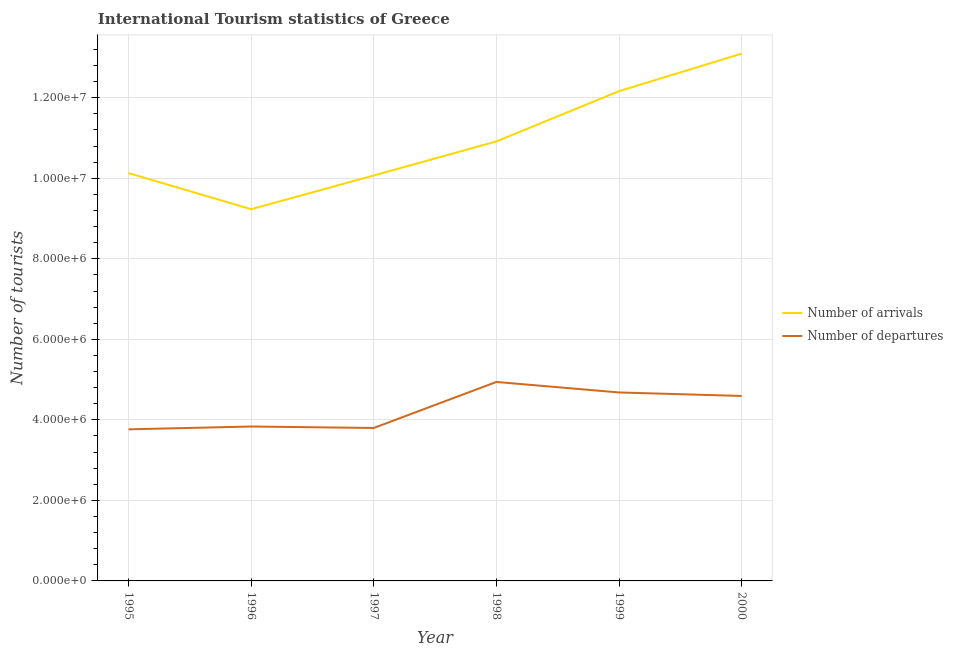How many different coloured lines are there?
Your response must be concise. 2. Does the line corresponding to number of tourist arrivals intersect with the line corresponding to number of tourist departures?
Your response must be concise. No. What is the number of tourist departures in 2000?
Your answer should be compact. 4.59e+06. Across all years, what is the maximum number of tourist departures?
Give a very brief answer. 4.94e+06. Across all years, what is the minimum number of tourist arrivals?
Your answer should be very brief. 9.23e+06. What is the total number of tourist arrivals in the graph?
Offer a terse response. 6.56e+07. What is the difference between the number of tourist departures in 1995 and that in 1998?
Offer a very short reply. -1.18e+06. What is the difference between the number of tourist arrivals in 1999 and the number of tourist departures in 1996?
Provide a succinct answer. 8.33e+06. What is the average number of tourist departures per year?
Make the answer very short. 4.27e+06. In the year 1996, what is the difference between the number of tourist arrivals and number of tourist departures?
Keep it short and to the point. 5.40e+06. What is the ratio of the number of tourist arrivals in 1997 to that in 1998?
Your response must be concise. 0.92. Is the difference between the number of tourist arrivals in 1995 and 1998 greater than the difference between the number of tourist departures in 1995 and 1998?
Your answer should be compact. Yes. What is the difference between the highest and the second highest number of tourist departures?
Your answer should be very brief. 2.61e+05. What is the difference between the highest and the lowest number of tourist departures?
Make the answer very short. 1.18e+06. In how many years, is the number of tourist departures greater than the average number of tourist departures taken over all years?
Make the answer very short. 3. Is the sum of the number of tourist arrivals in 1995 and 2000 greater than the maximum number of tourist departures across all years?
Provide a succinct answer. Yes. Is the number of tourist departures strictly less than the number of tourist arrivals over the years?
Provide a short and direct response. Yes. How many lines are there?
Make the answer very short. 2. How many years are there in the graph?
Provide a succinct answer. 6. What is the difference between two consecutive major ticks on the Y-axis?
Offer a very short reply. 2.00e+06. Does the graph contain grids?
Your response must be concise. Yes. How many legend labels are there?
Provide a short and direct response. 2. How are the legend labels stacked?
Your answer should be very brief. Vertical. What is the title of the graph?
Your answer should be compact. International Tourism statistics of Greece. Does "Resident" appear as one of the legend labels in the graph?
Give a very brief answer. No. What is the label or title of the X-axis?
Ensure brevity in your answer.  Year. What is the label or title of the Y-axis?
Offer a very short reply. Number of tourists. What is the Number of tourists in Number of arrivals in 1995?
Make the answer very short. 1.01e+07. What is the Number of tourists in Number of departures in 1995?
Offer a very short reply. 3.76e+06. What is the Number of tourists in Number of arrivals in 1996?
Your answer should be very brief. 9.23e+06. What is the Number of tourists of Number of departures in 1996?
Keep it short and to the point. 3.84e+06. What is the Number of tourists of Number of arrivals in 1997?
Your answer should be very brief. 1.01e+07. What is the Number of tourists in Number of departures in 1997?
Offer a terse response. 3.80e+06. What is the Number of tourists in Number of arrivals in 1998?
Provide a short and direct response. 1.09e+07. What is the Number of tourists of Number of departures in 1998?
Provide a short and direct response. 4.94e+06. What is the Number of tourists of Number of arrivals in 1999?
Ensure brevity in your answer.  1.22e+07. What is the Number of tourists of Number of departures in 1999?
Keep it short and to the point. 4.68e+06. What is the Number of tourists of Number of arrivals in 2000?
Offer a very short reply. 1.31e+07. What is the Number of tourists of Number of departures in 2000?
Your response must be concise. 4.59e+06. Across all years, what is the maximum Number of tourists of Number of arrivals?
Ensure brevity in your answer.  1.31e+07. Across all years, what is the maximum Number of tourists in Number of departures?
Provide a short and direct response. 4.94e+06. Across all years, what is the minimum Number of tourists of Number of arrivals?
Offer a very short reply. 9.23e+06. Across all years, what is the minimum Number of tourists of Number of departures?
Provide a succinct answer. 3.76e+06. What is the total Number of tourists of Number of arrivals in the graph?
Keep it short and to the point. 6.56e+07. What is the total Number of tourists in Number of departures in the graph?
Provide a succinct answer. 2.56e+07. What is the difference between the Number of tourists in Number of arrivals in 1995 and that in 1996?
Offer a very short reply. 8.97e+05. What is the difference between the Number of tourists of Number of departures in 1995 and that in 1997?
Keep it short and to the point. -3.40e+04. What is the difference between the Number of tourists of Number of arrivals in 1995 and that in 1998?
Provide a succinct answer. -7.86e+05. What is the difference between the Number of tourists in Number of departures in 1995 and that in 1998?
Your answer should be very brief. -1.18e+06. What is the difference between the Number of tourists in Number of arrivals in 1995 and that in 1999?
Your response must be concise. -2.03e+06. What is the difference between the Number of tourists in Number of departures in 1995 and that in 1999?
Ensure brevity in your answer.  -9.16e+05. What is the difference between the Number of tourists in Number of arrivals in 1995 and that in 2000?
Make the answer very short. -2.97e+06. What is the difference between the Number of tourists of Number of departures in 1995 and that in 2000?
Keep it short and to the point. -8.29e+05. What is the difference between the Number of tourists in Number of arrivals in 1996 and that in 1997?
Keep it short and to the point. -8.37e+05. What is the difference between the Number of tourists in Number of departures in 1996 and that in 1997?
Give a very brief answer. 3.60e+04. What is the difference between the Number of tourists in Number of arrivals in 1996 and that in 1998?
Offer a very short reply. -1.68e+06. What is the difference between the Number of tourists of Number of departures in 1996 and that in 1998?
Make the answer very short. -1.11e+06. What is the difference between the Number of tourists of Number of arrivals in 1996 and that in 1999?
Provide a succinct answer. -2.93e+06. What is the difference between the Number of tourists of Number of departures in 1996 and that in 1999?
Offer a very short reply. -8.46e+05. What is the difference between the Number of tourists of Number of arrivals in 1996 and that in 2000?
Make the answer very short. -3.86e+06. What is the difference between the Number of tourists in Number of departures in 1996 and that in 2000?
Ensure brevity in your answer.  -7.59e+05. What is the difference between the Number of tourists in Number of arrivals in 1997 and that in 1998?
Offer a very short reply. -8.46e+05. What is the difference between the Number of tourists in Number of departures in 1997 and that in 1998?
Your answer should be compact. -1.14e+06. What is the difference between the Number of tourists of Number of arrivals in 1997 and that in 1999?
Your answer should be compact. -2.09e+06. What is the difference between the Number of tourists in Number of departures in 1997 and that in 1999?
Ensure brevity in your answer.  -8.82e+05. What is the difference between the Number of tourists in Number of arrivals in 1997 and that in 2000?
Keep it short and to the point. -3.03e+06. What is the difference between the Number of tourists in Number of departures in 1997 and that in 2000?
Keep it short and to the point. -7.95e+05. What is the difference between the Number of tourists in Number of arrivals in 1998 and that in 1999?
Give a very brief answer. -1.25e+06. What is the difference between the Number of tourists of Number of departures in 1998 and that in 1999?
Your response must be concise. 2.61e+05. What is the difference between the Number of tourists of Number of arrivals in 1998 and that in 2000?
Your response must be concise. -2.18e+06. What is the difference between the Number of tourists in Number of departures in 1998 and that in 2000?
Make the answer very short. 3.48e+05. What is the difference between the Number of tourists of Number of arrivals in 1999 and that in 2000?
Keep it short and to the point. -9.32e+05. What is the difference between the Number of tourists of Number of departures in 1999 and that in 2000?
Give a very brief answer. 8.70e+04. What is the difference between the Number of tourists of Number of arrivals in 1995 and the Number of tourists of Number of departures in 1996?
Your answer should be very brief. 6.30e+06. What is the difference between the Number of tourists of Number of arrivals in 1995 and the Number of tourists of Number of departures in 1997?
Offer a very short reply. 6.33e+06. What is the difference between the Number of tourists of Number of arrivals in 1995 and the Number of tourists of Number of departures in 1998?
Ensure brevity in your answer.  5.19e+06. What is the difference between the Number of tourists in Number of arrivals in 1995 and the Number of tourists in Number of departures in 1999?
Provide a succinct answer. 5.45e+06. What is the difference between the Number of tourists of Number of arrivals in 1995 and the Number of tourists of Number of departures in 2000?
Make the answer very short. 5.54e+06. What is the difference between the Number of tourists in Number of arrivals in 1996 and the Number of tourists in Number of departures in 1997?
Give a very brief answer. 5.43e+06. What is the difference between the Number of tourists of Number of arrivals in 1996 and the Number of tourists of Number of departures in 1998?
Offer a terse response. 4.29e+06. What is the difference between the Number of tourists in Number of arrivals in 1996 and the Number of tourists in Number of departures in 1999?
Give a very brief answer. 4.55e+06. What is the difference between the Number of tourists of Number of arrivals in 1996 and the Number of tourists of Number of departures in 2000?
Keep it short and to the point. 4.64e+06. What is the difference between the Number of tourists in Number of arrivals in 1997 and the Number of tourists in Number of departures in 1998?
Ensure brevity in your answer.  5.13e+06. What is the difference between the Number of tourists in Number of arrivals in 1997 and the Number of tourists in Number of departures in 1999?
Offer a very short reply. 5.39e+06. What is the difference between the Number of tourists of Number of arrivals in 1997 and the Number of tourists of Number of departures in 2000?
Make the answer very short. 5.48e+06. What is the difference between the Number of tourists in Number of arrivals in 1998 and the Number of tourists in Number of departures in 1999?
Your answer should be compact. 6.24e+06. What is the difference between the Number of tourists in Number of arrivals in 1998 and the Number of tourists in Number of departures in 2000?
Provide a succinct answer. 6.32e+06. What is the difference between the Number of tourists in Number of arrivals in 1999 and the Number of tourists in Number of departures in 2000?
Ensure brevity in your answer.  7.57e+06. What is the average Number of tourists of Number of arrivals per year?
Provide a succinct answer. 1.09e+07. What is the average Number of tourists in Number of departures per year?
Keep it short and to the point. 4.27e+06. In the year 1995, what is the difference between the Number of tourists of Number of arrivals and Number of tourists of Number of departures?
Provide a succinct answer. 6.36e+06. In the year 1996, what is the difference between the Number of tourists in Number of arrivals and Number of tourists in Number of departures?
Provide a succinct answer. 5.40e+06. In the year 1997, what is the difference between the Number of tourists in Number of arrivals and Number of tourists in Number of departures?
Keep it short and to the point. 6.27e+06. In the year 1998, what is the difference between the Number of tourists in Number of arrivals and Number of tourists in Number of departures?
Offer a very short reply. 5.97e+06. In the year 1999, what is the difference between the Number of tourists of Number of arrivals and Number of tourists of Number of departures?
Provide a succinct answer. 7.48e+06. In the year 2000, what is the difference between the Number of tourists of Number of arrivals and Number of tourists of Number of departures?
Make the answer very short. 8.50e+06. What is the ratio of the Number of tourists of Number of arrivals in 1995 to that in 1996?
Your response must be concise. 1.1. What is the ratio of the Number of tourists in Number of departures in 1995 to that in 1996?
Your answer should be very brief. 0.98. What is the ratio of the Number of tourists in Number of departures in 1995 to that in 1997?
Your answer should be very brief. 0.99. What is the ratio of the Number of tourists of Number of arrivals in 1995 to that in 1998?
Your response must be concise. 0.93. What is the ratio of the Number of tourists of Number of departures in 1995 to that in 1998?
Your response must be concise. 0.76. What is the ratio of the Number of tourists of Number of arrivals in 1995 to that in 1999?
Keep it short and to the point. 0.83. What is the ratio of the Number of tourists in Number of departures in 1995 to that in 1999?
Provide a short and direct response. 0.8. What is the ratio of the Number of tourists of Number of arrivals in 1995 to that in 2000?
Make the answer very short. 0.77. What is the ratio of the Number of tourists of Number of departures in 1995 to that in 2000?
Provide a short and direct response. 0.82. What is the ratio of the Number of tourists in Number of arrivals in 1996 to that in 1997?
Make the answer very short. 0.92. What is the ratio of the Number of tourists of Number of departures in 1996 to that in 1997?
Make the answer very short. 1.01. What is the ratio of the Number of tourists of Number of arrivals in 1996 to that in 1998?
Your answer should be compact. 0.85. What is the ratio of the Number of tourists in Number of departures in 1996 to that in 1998?
Your answer should be very brief. 0.78. What is the ratio of the Number of tourists in Number of arrivals in 1996 to that in 1999?
Offer a very short reply. 0.76. What is the ratio of the Number of tourists of Number of departures in 1996 to that in 1999?
Give a very brief answer. 0.82. What is the ratio of the Number of tourists in Number of arrivals in 1996 to that in 2000?
Your response must be concise. 0.7. What is the ratio of the Number of tourists of Number of departures in 1996 to that in 2000?
Your answer should be very brief. 0.83. What is the ratio of the Number of tourists of Number of arrivals in 1997 to that in 1998?
Your answer should be very brief. 0.92. What is the ratio of the Number of tourists in Number of departures in 1997 to that in 1998?
Make the answer very short. 0.77. What is the ratio of the Number of tourists in Number of arrivals in 1997 to that in 1999?
Your response must be concise. 0.83. What is the ratio of the Number of tourists of Number of departures in 1997 to that in 1999?
Make the answer very short. 0.81. What is the ratio of the Number of tourists in Number of arrivals in 1997 to that in 2000?
Your answer should be compact. 0.77. What is the ratio of the Number of tourists of Number of departures in 1997 to that in 2000?
Your response must be concise. 0.83. What is the ratio of the Number of tourists of Number of arrivals in 1998 to that in 1999?
Provide a short and direct response. 0.9. What is the ratio of the Number of tourists of Number of departures in 1998 to that in 1999?
Give a very brief answer. 1.06. What is the ratio of the Number of tourists of Number of arrivals in 1998 to that in 2000?
Keep it short and to the point. 0.83. What is the ratio of the Number of tourists in Number of departures in 1998 to that in 2000?
Provide a succinct answer. 1.08. What is the ratio of the Number of tourists in Number of arrivals in 1999 to that in 2000?
Your response must be concise. 0.93. What is the ratio of the Number of tourists in Number of departures in 1999 to that in 2000?
Your answer should be compact. 1.02. What is the difference between the highest and the second highest Number of tourists of Number of arrivals?
Your answer should be very brief. 9.32e+05. What is the difference between the highest and the second highest Number of tourists of Number of departures?
Keep it short and to the point. 2.61e+05. What is the difference between the highest and the lowest Number of tourists of Number of arrivals?
Provide a succinct answer. 3.86e+06. What is the difference between the highest and the lowest Number of tourists of Number of departures?
Keep it short and to the point. 1.18e+06. 